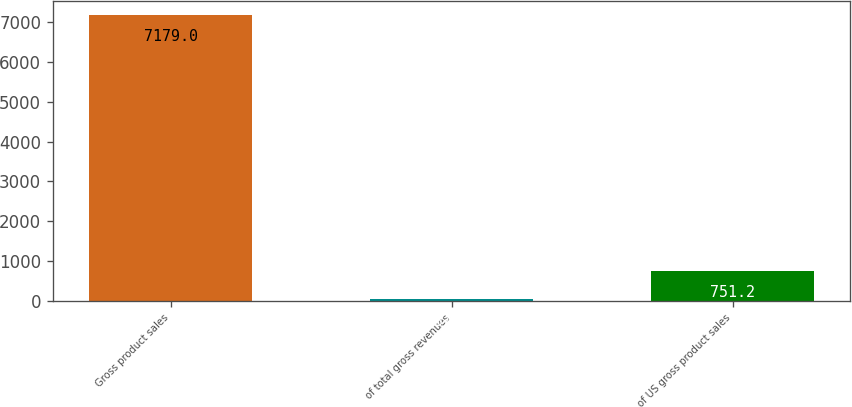Convert chart to OTSL. <chart><loc_0><loc_0><loc_500><loc_500><bar_chart><fcel>Gross product sales<fcel>of total gross revenues<fcel>of US gross product sales<nl><fcel>7179<fcel>37<fcel>751.2<nl></chart> 